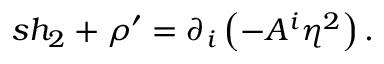<formula> <loc_0><loc_0><loc_500><loc_500>s h _ { 2 } + \rho ^ { \prime } = \partial _ { i } \left ( - A ^ { i } \eta ^ { 2 } \right ) .</formula> 